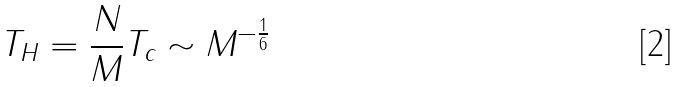Convert formula to latex. <formula><loc_0><loc_0><loc_500><loc_500>T _ { H } = \frac { N } { M } T _ { c } \sim M ^ { - \frac { 1 } { 6 } }</formula> 